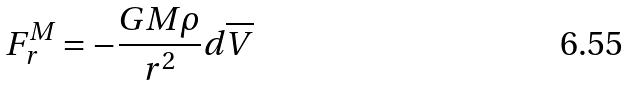Convert formula to latex. <formula><loc_0><loc_0><loc_500><loc_500>F _ { r } ^ { M } = - \frac { G M \rho } { r ^ { 2 } } d \overline { V }</formula> 